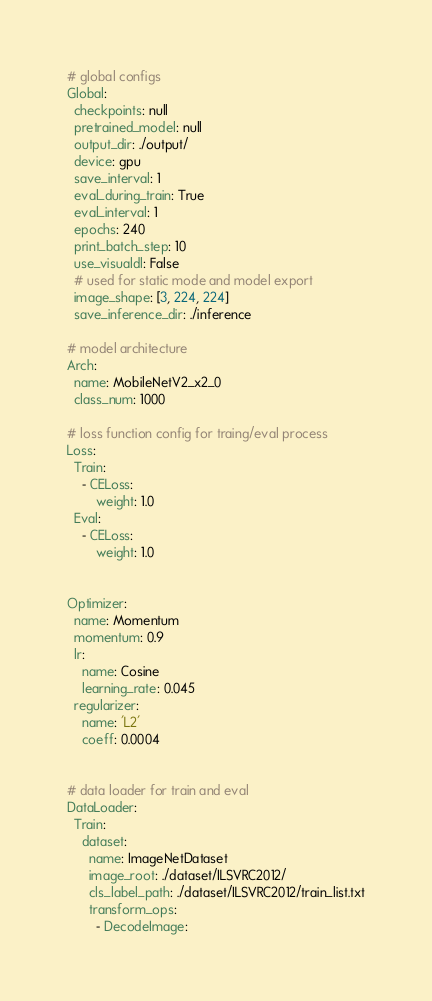Convert code to text. <code><loc_0><loc_0><loc_500><loc_500><_YAML_># global configs
Global:
  checkpoints: null
  pretrained_model: null
  output_dir: ./output/
  device: gpu
  save_interval: 1
  eval_during_train: True
  eval_interval: 1
  epochs: 240
  print_batch_step: 10
  use_visualdl: False
  # used for static mode and model export
  image_shape: [3, 224, 224]
  save_inference_dir: ./inference

# model architecture
Arch:
  name: MobileNetV2_x2_0
  class_num: 1000
 
# loss function config for traing/eval process
Loss:
  Train:
    - CELoss:
        weight: 1.0
  Eval:
    - CELoss:
        weight: 1.0


Optimizer:
  name: Momentum
  momentum: 0.9
  lr:
    name: Cosine
    learning_rate: 0.045
  regularizer:
    name: 'L2'
    coeff: 0.0004


# data loader for train and eval
DataLoader:
  Train:
    dataset:
      name: ImageNetDataset
      image_root: ./dataset/ILSVRC2012/
      cls_label_path: ./dataset/ILSVRC2012/train_list.txt
      transform_ops:
        - DecodeImage:</code> 